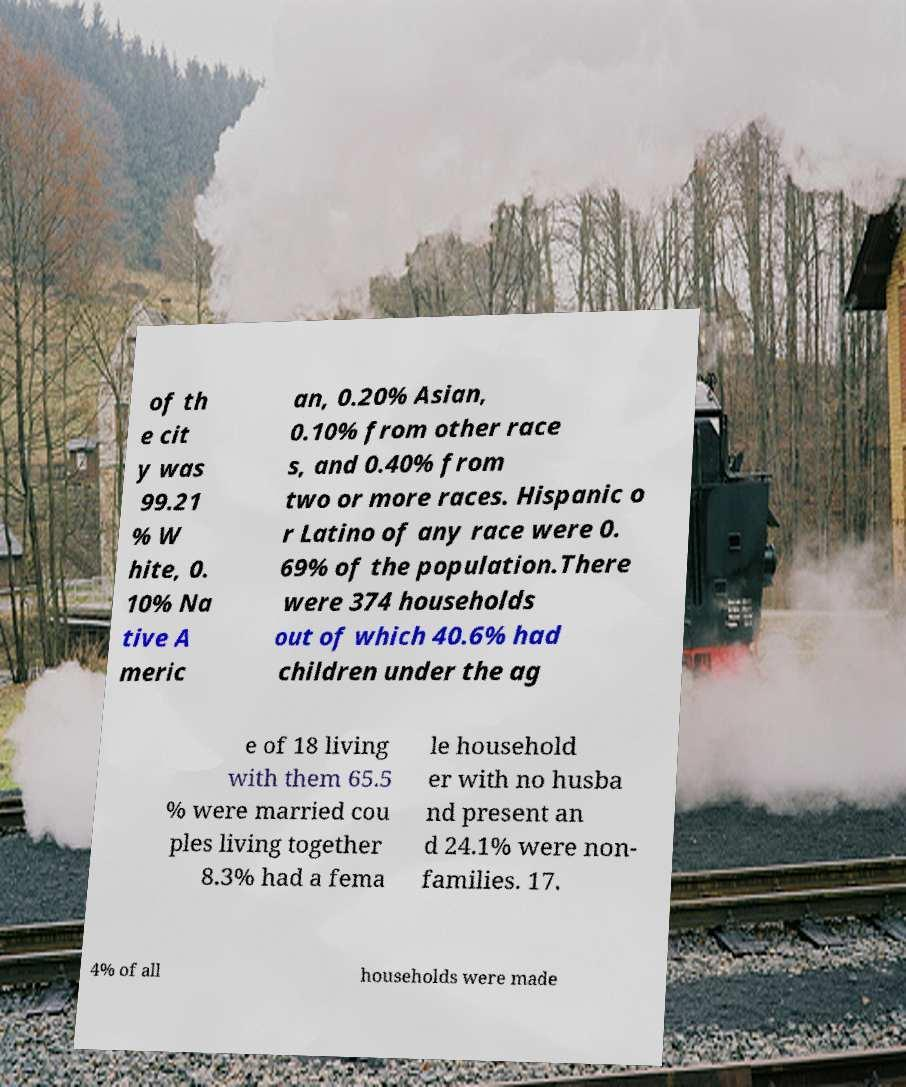Could you assist in decoding the text presented in this image and type it out clearly? of th e cit y was 99.21 % W hite, 0. 10% Na tive A meric an, 0.20% Asian, 0.10% from other race s, and 0.40% from two or more races. Hispanic o r Latino of any race were 0. 69% of the population.There were 374 households out of which 40.6% had children under the ag e of 18 living with them 65.5 % were married cou ples living together 8.3% had a fema le household er with no husba nd present an d 24.1% were non- families. 17. 4% of all households were made 